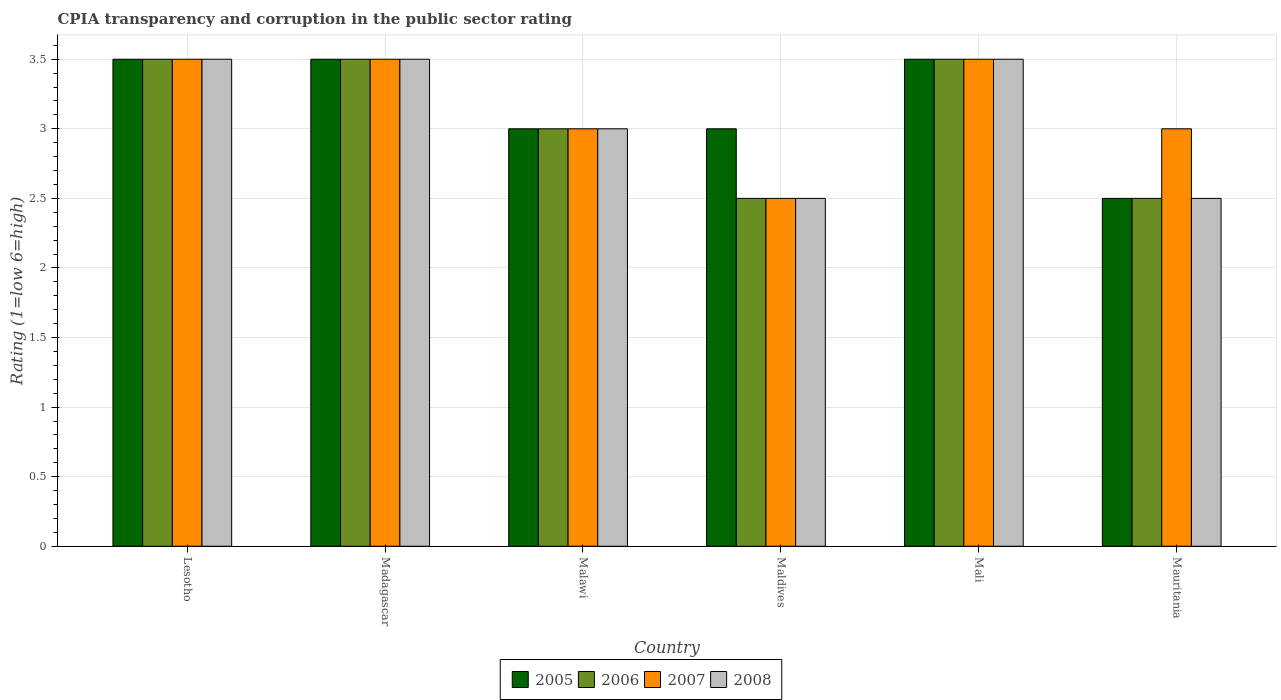How many groups of bars are there?
Make the answer very short. 6. Are the number of bars on each tick of the X-axis equal?
Keep it short and to the point. Yes. What is the label of the 3rd group of bars from the left?
Give a very brief answer. Malawi. In how many cases, is the number of bars for a given country not equal to the number of legend labels?
Keep it short and to the point. 0. What is the CPIA rating in 2008 in Maldives?
Your answer should be very brief. 2.5. Across all countries, what is the maximum CPIA rating in 2008?
Provide a short and direct response. 3.5. In which country was the CPIA rating in 2008 maximum?
Keep it short and to the point. Lesotho. In which country was the CPIA rating in 2008 minimum?
Ensure brevity in your answer.  Maldives. What is the average CPIA rating in 2008 per country?
Your response must be concise. 3.08. What is the ratio of the CPIA rating in 2005 in Malawi to that in Maldives?
Your answer should be very brief. 1. Is the CPIA rating in 2006 in Madagascar less than that in Mauritania?
Your answer should be very brief. No. Is the difference between the CPIA rating in 2005 in Madagascar and Maldives greater than the difference between the CPIA rating in 2007 in Madagascar and Maldives?
Provide a succinct answer. No. In how many countries, is the CPIA rating in 2007 greater than the average CPIA rating in 2007 taken over all countries?
Provide a succinct answer. 3. Is the sum of the CPIA rating in 2008 in Madagascar and Maldives greater than the maximum CPIA rating in 2005 across all countries?
Make the answer very short. Yes. What does the 3rd bar from the right in Maldives represents?
Make the answer very short. 2006. Is it the case that in every country, the sum of the CPIA rating in 2008 and CPIA rating in 2006 is greater than the CPIA rating in 2007?
Keep it short and to the point. Yes. How many bars are there?
Give a very brief answer. 24. Are all the bars in the graph horizontal?
Keep it short and to the point. No. How many countries are there in the graph?
Provide a short and direct response. 6. Are the values on the major ticks of Y-axis written in scientific E-notation?
Provide a succinct answer. No. Does the graph contain grids?
Provide a succinct answer. Yes. Where does the legend appear in the graph?
Make the answer very short. Bottom center. How many legend labels are there?
Provide a succinct answer. 4. What is the title of the graph?
Ensure brevity in your answer.  CPIA transparency and corruption in the public sector rating. What is the label or title of the X-axis?
Keep it short and to the point. Country. What is the Rating (1=low 6=high) of 2005 in Lesotho?
Provide a succinct answer. 3.5. What is the Rating (1=low 6=high) of 2008 in Lesotho?
Provide a succinct answer. 3.5. What is the Rating (1=low 6=high) of 2005 in Madagascar?
Ensure brevity in your answer.  3.5. What is the Rating (1=low 6=high) in 2008 in Madagascar?
Offer a terse response. 3.5. What is the Rating (1=low 6=high) of 2005 in Malawi?
Offer a terse response. 3. What is the Rating (1=low 6=high) in 2006 in Malawi?
Make the answer very short. 3. What is the Rating (1=low 6=high) of 2006 in Maldives?
Offer a very short reply. 2.5. What is the Rating (1=low 6=high) of 2005 in Mali?
Your answer should be very brief. 3.5. What is the Rating (1=low 6=high) of 2006 in Mali?
Your response must be concise. 3.5. What is the Rating (1=low 6=high) in 2007 in Mali?
Offer a terse response. 3.5. What is the Rating (1=low 6=high) of 2008 in Mali?
Keep it short and to the point. 3.5. What is the Rating (1=low 6=high) in 2005 in Mauritania?
Your answer should be compact. 2.5. What is the Rating (1=low 6=high) of 2007 in Mauritania?
Keep it short and to the point. 3. Across all countries, what is the maximum Rating (1=low 6=high) of 2005?
Your answer should be very brief. 3.5. Across all countries, what is the maximum Rating (1=low 6=high) in 2006?
Provide a short and direct response. 3.5. Across all countries, what is the maximum Rating (1=low 6=high) in 2007?
Provide a short and direct response. 3.5. Across all countries, what is the maximum Rating (1=low 6=high) in 2008?
Your answer should be very brief. 3.5. Across all countries, what is the minimum Rating (1=low 6=high) of 2005?
Keep it short and to the point. 2.5. Across all countries, what is the minimum Rating (1=low 6=high) in 2006?
Provide a short and direct response. 2.5. Across all countries, what is the minimum Rating (1=low 6=high) in 2007?
Provide a short and direct response. 2.5. Across all countries, what is the minimum Rating (1=low 6=high) of 2008?
Provide a short and direct response. 2.5. What is the total Rating (1=low 6=high) in 2005 in the graph?
Give a very brief answer. 19. What is the difference between the Rating (1=low 6=high) in 2005 in Lesotho and that in Madagascar?
Give a very brief answer. 0. What is the difference between the Rating (1=low 6=high) in 2007 in Lesotho and that in Madagascar?
Provide a succinct answer. 0. What is the difference between the Rating (1=low 6=high) in 2008 in Lesotho and that in Madagascar?
Ensure brevity in your answer.  0. What is the difference between the Rating (1=low 6=high) of 2005 in Lesotho and that in Malawi?
Your response must be concise. 0.5. What is the difference between the Rating (1=low 6=high) of 2006 in Lesotho and that in Malawi?
Offer a very short reply. 0.5. What is the difference between the Rating (1=low 6=high) of 2007 in Lesotho and that in Malawi?
Your answer should be very brief. 0.5. What is the difference between the Rating (1=low 6=high) of 2005 in Lesotho and that in Maldives?
Give a very brief answer. 0.5. What is the difference between the Rating (1=low 6=high) in 2006 in Lesotho and that in Maldives?
Give a very brief answer. 1. What is the difference between the Rating (1=low 6=high) in 2007 in Lesotho and that in Maldives?
Your response must be concise. 1. What is the difference between the Rating (1=low 6=high) of 2008 in Lesotho and that in Maldives?
Provide a succinct answer. 1. What is the difference between the Rating (1=low 6=high) in 2005 in Lesotho and that in Mali?
Give a very brief answer. 0. What is the difference between the Rating (1=low 6=high) of 2008 in Lesotho and that in Mali?
Provide a succinct answer. 0. What is the difference between the Rating (1=low 6=high) in 2005 in Lesotho and that in Mauritania?
Offer a terse response. 1. What is the difference between the Rating (1=low 6=high) in 2006 in Madagascar and that in Malawi?
Offer a terse response. 0.5. What is the difference between the Rating (1=low 6=high) of 2008 in Madagascar and that in Malawi?
Provide a succinct answer. 0.5. What is the difference between the Rating (1=low 6=high) in 2005 in Madagascar and that in Maldives?
Provide a succinct answer. 0.5. What is the difference between the Rating (1=low 6=high) of 2006 in Madagascar and that in Maldives?
Offer a very short reply. 1. What is the difference between the Rating (1=low 6=high) in 2007 in Madagascar and that in Maldives?
Provide a succinct answer. 1. What is the difference between the Rating (1=low 6=high) in 2008 in Madagascar and that in Maldives?
Provide a short and direct response. 1. What is the difference between the Rating (1=low 6=high) of 2005 in Madagascar and that in Mali?
Provide a short and direct response. 0. What is the difference between the Rating (1=low 6=high) in 2005 in Madagascar and that in Mauritania?
Provide a short and direct response. 1. What is the difference between the Rating (1=low 6=high) of 2006 in Madagascar and that in Mauritania?
Provide a short and direct response. 1. What is the difference between the Rating (1=low 6=high) in 2008 in Madagascar and that in Mauritania?
Offer a very short reply. 1. What is the difference between the Rating (1=low 6=high) of 2005 in Malawi and that in Maldives?
Keep it short and to the point. 0. What is the difference between the Rating (1=low 6=high) of 2008 in Malawi and that in Maldives?
Make the answer very short. 0.5. What is the difference between the Rating (1=low 6=high) of 2006 in Malawi and that in Mali?
Your answer should be very brief. -0.5. What is the difference between the Rating (1=low 6=high) of 2007 in Malawi and that in Mali?
Keep it short and to the point. -0.5. What is the difference between the Rating (1=low 6=high) of 2008 in Malawi and that in Mali?
Give a very brief answer. -0.5. What is the difference between the Rating (1=low 6=high) in 2007 in Malawi and that in Mauritania?
Your answer should be very brief. 0. What is the difference between the Rating (1=low 6=high) of 2008 in Malawi and that in Mauritania?
Keep it short and to the point. 0.5. What is the difference between the Rating (1=low 6=high) of 2005 in Maldives and that in Mali?
Make the answer very short. -0.5. What is the difference between the Rating (1=low 6=high) of 2006 in Maldives and that in Mali?
Provide a succinct answer. -1. What is the difference between the Rating (1=low 6=high) in 2007 in Maldives and that in Mali?
Offer a terse response. -1. What is the difference between the Rating (1=low 6=high) in 2006 in Maldives and that in Mauritania?
Keep it short and to the point. 0. What is the difference between the Rating (1=low 6=high) in 2005 in Mali and that in Mauritania?
Provide a succinct answer. 1. What is the difference between the Rating (1=low 6=high) in 2006 in Mali and that in Mauritania?
Ensure brevity in your answer.  1. What is the difference between the Rating (1=low 6=high) in 2007 in Mali and that in Mauritania?
Give a very brief answer. 0.5. What is the difference between the Rating (1=low 6=high) of 2005 in Lesotho and the Rating (1=low 6=high) of 2007 in Madagascar?
Make the answer very short. 0. What is the difference between the Rating (1=low 6=high) in 2005 in Lesotho and the Rating (1=low 6=high) in 2008 in Madagascar?
Provide a succinct answer. 0. What is the difference between the Rating (1=low 6=high) of 2006 in Lesotho and the Rating (1=low 6=high) of 2007 in Madagascar?
Provide a short and direct response. 0. What is the difference between the Rating (1=low 6=high) in 2006 in Lesotho and the Rating (1=low 6=high) in 2007 in Malawi?
Offer a very short reply. 0.5. What is the difference between the Rating (1=low 6=high) of 2006 in Lesotho and the Rating (1=low 6=high) of 2008 in Malawi?
Your answer should be very brief. 0.5. What is the difference between the Rating (1=low 6=high) in 2007 in Lesotho and the Rating (1=low 6=high) in 2008 in Malawi?
Provide a succinct answer. 0.5. What is the difference between the Rating (1=low 6=high) of 2005 in Lesotho and the Rating (1=low 6=high) of 2006 in Maldives?
Ensure brevity in your answer.  1. What is the difference between the Rating (1=low 6=high) of 2005 in Lesotho and the Rating (1=low 6=high) of 2008 in Maldives?
Your answer should be compact. 1. What is the difference between the Rating (1=low 6=high) in 2006 in Lesotho and the Rating (1=low 6=high) in 2007 in Maldives?
Ensure brevity in your answer.  1. What is the difference between the Rating (1=low 6=high) of 2006 in Lesotho and the Rating (1=low 6=high) of 2008 in Maldives?
Your response must be concise. 1. What is the difference between the Rating (1=low 6=high) in 2007 in Lesotho and the Rating (1=low 6=high) in 2008 in Maldives?
Make the answer very short. 1. What is the difference between the Rating (1=low 6=high) of 2005 in Lesotho and the Rating (1=low 6=high) of 2007 in Mali?
Keep it short and to the point. 0. What is the difference between the Rating (1=low 6=high) of 2005 in Lesotho and the Rating (1=low 6=high) of 2008 in Mali?
Offer a terse response. 0. What is the difference between the Rating (1=low 6=high) of 2006 in Lesotho and the Rating (1=low 6=high) of 2008 in Mali?
Your response must be concise. 0. What is the difference between the Rating (1=low 6=high) of 2005 in Lesotho and the Rating (1=low 6=high) of 2008 in Mauritania?
Provide a short and direct response. 1. What is the difference between the Rating (1=low 6=high) of 2006 in Lesotho and the Rating (1=low 6=high) of 2008 in Mauritania?
Keep it short and to the point. 1. What is the difference between the Rating (1=low 6=high) of 2005 in Madagascar and the Rating (1=low 6=high) of 2008 in Malawi?
Offer a terse response. 0.5. What is the difference between the Rating (1=low 6=high) of 2006 in Madagascar and the Rating (1=low 6=high) of 2008 in Malawi?
Keep it short and to the point. 0.5. What is the difference between the Rating (1=low 6=high) of 2007 in Madagascar and the Rating (1=low 6=high) of 2008 in Malawi?
Your answer should be compact. 0.5. What is the difference between the Rating (1=low 6=high) of 2005 in Madagascar and the Rating (1=low 6=high) of 2006 in Maldives?
Your response must be concise. 1. What is the difference between the Rating (1=low 6=high) in 2005 in Madagascar and the Rating (1=low 6=high) in 2008 in Maldives?
Make the answer very short. 1. What is the difference between the Rating (1=low 6=high) of 2006 in Madagascar and the Rating (1=low 6=high) of 2007 in Maldives?
Your response must be concise. 1. What is the difference between the Rating (1=low 6=high) of 2006 in Madagascar and the Rating (1=low 6=high) of 2008 in Maldives?
Your response must be concise. 1. What is the difference between the Rating (1=low 6=high) of 2007 in Madagascar and the Rating (1=low 6=high) of 2008 in Maldives?
Offer a very short reply. 1. What is the difference between the Rating (1=low 6=high) in 2005 in Madagascar and the Rating (1=low 6=high) in 2007 in Mali?
Your answer should be very brief. 0. What is the difference between the Rating (1=low 6=high) in 2005 in Madagascar and the Rating (1=low 6=high) in 2008 in Mali?
Offer a terse response. 0. What is the difference between the Rating (1=low 6=high) in 2007 in Madagascar and the Rating (1=low 6=high) in 2008 in Mali?
Your response must be concise. 0. What is the difference between the Rating (1=low 6=high) in 2005 in Madagascar and the Rating (1=low 6=high) in 2006 in Mauritania?
Your answer should be compact. 1. What is the difference between the Rating (1=low 6=high) in 2005 in Madagascar and the Rating (1=low 6=high) in 2007 in Mauritania?
Ensure brevity in your answer.  0.5. What is the difference between the Rating (1=low 6=high) in 2007 in Madagascar and the Rating (1=low 6=high) in 2008 in Mauritania?
Make the answer very short. 1. What is the difference between the Rating (1=low 6=high) of 2005 in Malawi and the Rating (1=low 6=high) of 2007 in Maldives?
Provide a succinct answer. 0.5. What is the difference between the Rating (1=low 6=high) in 2005 in Malawi and the Rating (1=low 6=high) in 2008 in Maldives?
Your answer should be very brief. 0.5. What is the difference between the Rating (1=low 6=high) of 2006 in Malawi and the Rating (1=low 6=high) of 2008 in Maldives?
Offer a terse response. 0.5. What is the difference between the Rating (1=low 6=high) in 2007 in Malawi and the Rating (1=low 6=high) in 2008 in Maldives?
Your response must be concise. 0.5. What is the difference between the Rating (1=low 6=high) in 2005 in Malawi and the Rating (1=low 6=high) in 2006 in Mali?
Offer a very short reply. -0.5. What is the difference between the Rating (1=low 6=high) of 2005 in Malawi and the Rating (1=low 6=high) of 2008 in Mali?
Your response must be concise. -0.5. What is the difference between the Rating (1=low 6=high) in 2006 in Malawi and the Rating (1=low 6=high) in 2007 in Mali?
Your answer should be compact. -0.5. What is the difference between the Rating (1=low 6=high) in 2005 in Malawi and the Rating (1=low 6=high) in 2008 in Mauritania?
Your response must be concise. 0.5. What is the difference between the Rating (1=low 6=high) of 2006 in Malawi and the Rating (1=low 6=high) of 2008 in Mauritania?
Offer a terse response. 0.5. What is the difference between the Rating (1=low 6=high) of 2005 in Maldives and the Rating (1=low 6=high) of 2006 in Mauritania?
Provide a succinct answer. 0.5. What is the difference between the Rating (1=low 6=high) of 2005 in Maldives and the Rating (1=low 6=high) of 2007 in Mauritania?
Keep it short and to the point. 0. What is the difference between the Rating (1=low 6=high) of 2005 in Maldives and the Rating (1=low 6=high) of 2008 in Mauritania?
Give a very brief answer. 0.5. What is the difference between the Rating (1=low 6=high) in 2006 in Maldives and the Rating (1=low 6=high) in 2008 in Mauritania?
Your answer should be compact. 0. What is the difference between the Rating (1=low 6=high) of 2005 in Mali and the Rating (1=low 6=high) of 2006 in Mauritania?
Give a very brief answer. 1. What is the difference between the Rating (1=low 6=high) in 2005 in Mali and the Rating (1=low 6=high) in 2007 in Mauritania?
Your response must be concise. 0.5. What is the difference between the Rating (1=low 6=high) of 2005 in Mali and the Rating (1=low 6=high) of 2008 in Mauritania?
Offer a terse response. 1. What is the difference between the Rating (1=low 6=high) of 2006 in Mali and the Rating (1=low 6=high) of 2007 in Mauritania?
Make the answer very short. 0.5. What is the average Rating (1=low 6=high) of 2005 per country?
Keep it short and to the point. 3.17. What is the average Rating (1=low 6=high) of 2006 per country?
Provide a short and direct response. 3.08. What is the average Rating (1=low 6=high) in 2007 per country?
Make the answer very short. 3.17. What is the average Rating (1=low 6=high) in 2008 per country?
Offer a very short reply. 3.08. What is the difference between the Rating (1=low 6=high) of 2005 and Rating (1=low 6=high) of 2007 in Lesotho?
Make the answer very short. 0. What is the difference between the Rating (1=low 6=high) in 2005 and Rating (1=low 6=high) in 2008 in Lesotho?
Provide a short and direct response. 0. What is the difference between the Rating (1=low 6=high) in 2006 and Rating (1=low 6=high) in 2008 in Lesotho?
Make the answer very short. 0. What is the difference between the Rating (1=low 6=high) in 2007 and Rating (1=low 6=high) in 2008 in Lesotho?
Offer a very short reply. 0. What is the difference between the Rating (1=low 6=high) of 2005 and Rating (1=low 6=high) of 2006 in Madagascar?
Your answer should be very brief. 0. What is the difference between the Rating (1=low 6=high) in 2005 and Rating (1=low 6=high) in 2007 in Madagascar?
Give a very brief answer. 0. What is the difference between the Rating (1=low 6=high) in 2005 and Rating (1=low 6=high) in 2008 in Madagascar?
Give a very brief answer. 0. What is the difference between the Rating (1=low 6=high) of 2006 and Rating (1=low 6=high) of 2007 in Madagascar?
Your response must be concise. 0. What is the difference between the Rating (1=low 6=high) of 2007 and Rating (1=low 6=high) of 2008 in Madagascar?
Offer a terse response. 0. What is the difference between the Rating (1=low 6=high) of 2005 and Rating (1=low 6=high) of 2006 in Malawi?
Offer a terse response. 0. What is the difference between the Rating (1=low 6=high) in 2006 and Rating (1=low 6=high) in 2007 in Malawi?
Your response must be concise. 0. What is the difference between the Rating (1=low 6=high) in 2006 and Rating (1=low 6=high) in 2008 in Malawi?
Your response must be concise. 0. What is the difference between the Rating (1=low 6=high) of 2007 and Rating (1=low 6=high) of 2008 in Malawi?
Make the answer very short. 0. What is the difference between the Rating (1=low 6=high) of 2005 and Rating (1=low 6=high) of 2007 in Maldives?
Make the answer very short. 0.5. What is the difference between the Rating (1=low 6=high) of 2005 and Rating (1=low 6=high) of 2008 in Maldives?
Ensure brevity in your answer.  0.5. What is the difference between the Rating (1=low 6=high) of 2006 and Rating (1=low 6=high) of 2007 in Maldives?
Keep it short and to the point. 0. What is the difference between the Rating (1=low 6=high) of 2007 and Rating (1=low 6=high) of 2008 in Maldives?
Offer a terse response. 0. What is the difference between the Rating (1=low 6=high) in 2005 and Rating (1=low 6=high) in 2006 in Mali?
Your response must be concise. 0. What is the difference between the Rating (1=low 6=high) of 2005 and Rating (1=low 6=high) of 2007 in Mali?
Your answer should be compact. 0. What is the difference between the Rating (1=low 6=high) of 2005 and Rating (1=low 6=high) of 2008 in Mali?
Ensure brevity in your answer.  0. What is the difference between the Rating (1=low 6=high) of 2006 and Rating (1=low 6=high) of 2007 in Mali?
Offer a very short reply. 0. What is the difference between the Rating (1=low 6=high) in 2006 and Rating (1=low 6=high) in 2008 in Mali?
Your answer should be very brief. 0. What is the difference between the Rating (1=low 6=high) of 2007 and Rating (1=low 6=high) of 2008 in Mali?
Your answer should be compact. 0. What is the difference between the Rating (1=low 6=high) in 2005 and Rating (1=low 6=high) in 2007 in Mauritania?
Your answer should be very brief. -0.5. What is the difference between the Rating (1=low 6=high) of 2006 and Rating (1=low 6=high) of 2007 in Mauritania?
Your answer should be very brief. -0.5. What is the difference between the Rating (1=low 6=high) in 2007 and Rating (1=low 6=high) in 2008 in Mauritania?
Give a very brief answer. 0.5. What is the ratio of the Rating (1=low 6=high) in 2007 in Lesotho to that in Madagascar?
Keep it short and to the point. 1. What is the ratio of the Rating (1=low 6=high) of 2007 in Lesotho to that in Malawi?
Ensure brevity in your answer.  1.17. What is the ratio of the Rating (1=low 6=high) in 2005 in Lesotho to that in Maldives?
Provide a short and direct response. 1.17. What is the ratio of the Rating (1=low 6=high) of 2007 in Lesotho to that in Maldives?
Provide a short and direct response. 1.4. What is the ratio of the Rating (1=low 6=high) in 2008 in Lesotho to that in Maldives?
Make the answer very short. 1.4. What is the ratio of the Rating (1=low 6=high) in 2005 in Lesotho to that in Mauritania?
Offer a very short reply. 1.4. What is the ratio of the Rating (1=low 6=high) in 2007 in Lesotho to that in Mauritania?
Your answer should be very brief. 1.17. What is the ratio of the Rating (1=low 6=high) of 2008 in Lesotho to that in Mauritania?
Your response must be concise. 1.4. What is the ratio of the Rating (1=low 6=high) in 2005 in Madagascar to that in Malawi?
Give a very brief answer. 1.17. What is the ratio of the Rating (1=low 6=high) of 2006 in Madagascar to that in Malawi?
Make the answer very short. 1.17. What is the ratio of the Rating (1=low 6=high) of 2007 in Madagascar to that in Malawi?
Keep it short and to the point. 1.17. What is the ratio of the Rating (1=low 6=high) of 2008 in Madagascar to that in Maldives?
Your answer should be very brief. 1.4. What is the ratio of the Rating (1=low 6=high) in 2005 in Madagascar to that in Mali?
Your answer should be very brief. 1. What is the ratio of the Rating (1=low 6=high) in 2005 in Madagascar to that in Mauritania?
Your response must be concise. 1.4. What is the ratio of the Rating (1=low 6=high) in 2006 in Madagascar to that in Mauritania?
Your response must be concise. 1.4. What is the ratio of the Rating (1=low 6=high) of 2007 in Madagascar to that in Mauritania?
Your response must be concise. 1.17. What is the ratio of the Rating (1=low 6=high) in 2006 in Malawi to that in Maldives?
Offer a terse response. 1.2. What is the ratio of the Rating (1=low 6=high) in 2007 in Malawi to that in Maldives?
Your answer should be very brief. 1.2. What is the ratio of the Rating (1=low 6=high) of 2008 in Malawi to that in Maldives?
Offer a terse response. 1.2. What is the ratio of the Rating (1=low 6=high) in 2007 in Malawi to that in Mali?
Ensure brevity in your answer.  0.86. What is the ratio of the Rating (1=low 6=high) of 2005 in Malawi to that in Mauritania?
Give a very brief answer. 1.2. What is the ratio of the Rating (1=low 6=high) of 2006 in Maldives to that in Mali?
Give a very brief answer. 0.71. What is the ratio of the Rating (1=low 6=high) of 2005 in Maldives to that in Mauritania?
Your response must be concise. 1.2. What is the ratio of the Rating (1=low 6=high) of 2006 in Maldives to that in Mauritania?
Offer a terse response. 1. What is the ratio of the Rating (1=low 6=high) of 2007 in Maldives to that in Mauritania?
Make the answer very short. 0.83. What is the ratio of the Rating (1=low 6=high) in 2008 in Maldives to that in Mauritania?
Offer a very short reply. 1. What is the ratio of the Rating (1=low 6=high) of 2007 in Mali to that in Mauritania?
Make the answer very short. 1.17. What is the ratio of the Rating (1=low 6=high) in 2008 in Mali to that in Mauritania?
Offer a very short reply. 1.4. What is the difference between the highest and the second highest Rating (1=low 6=high) of 2005?
Offer a terse response. 0. What is the difference between the highest and the second highest Rating (1=low 6=high) of 2006?
Your answer should be very brief. 0. What is the difference between the highest and the lowest Rating (1=low 6=high) of 2008?
Your answer should be compact. 1. 